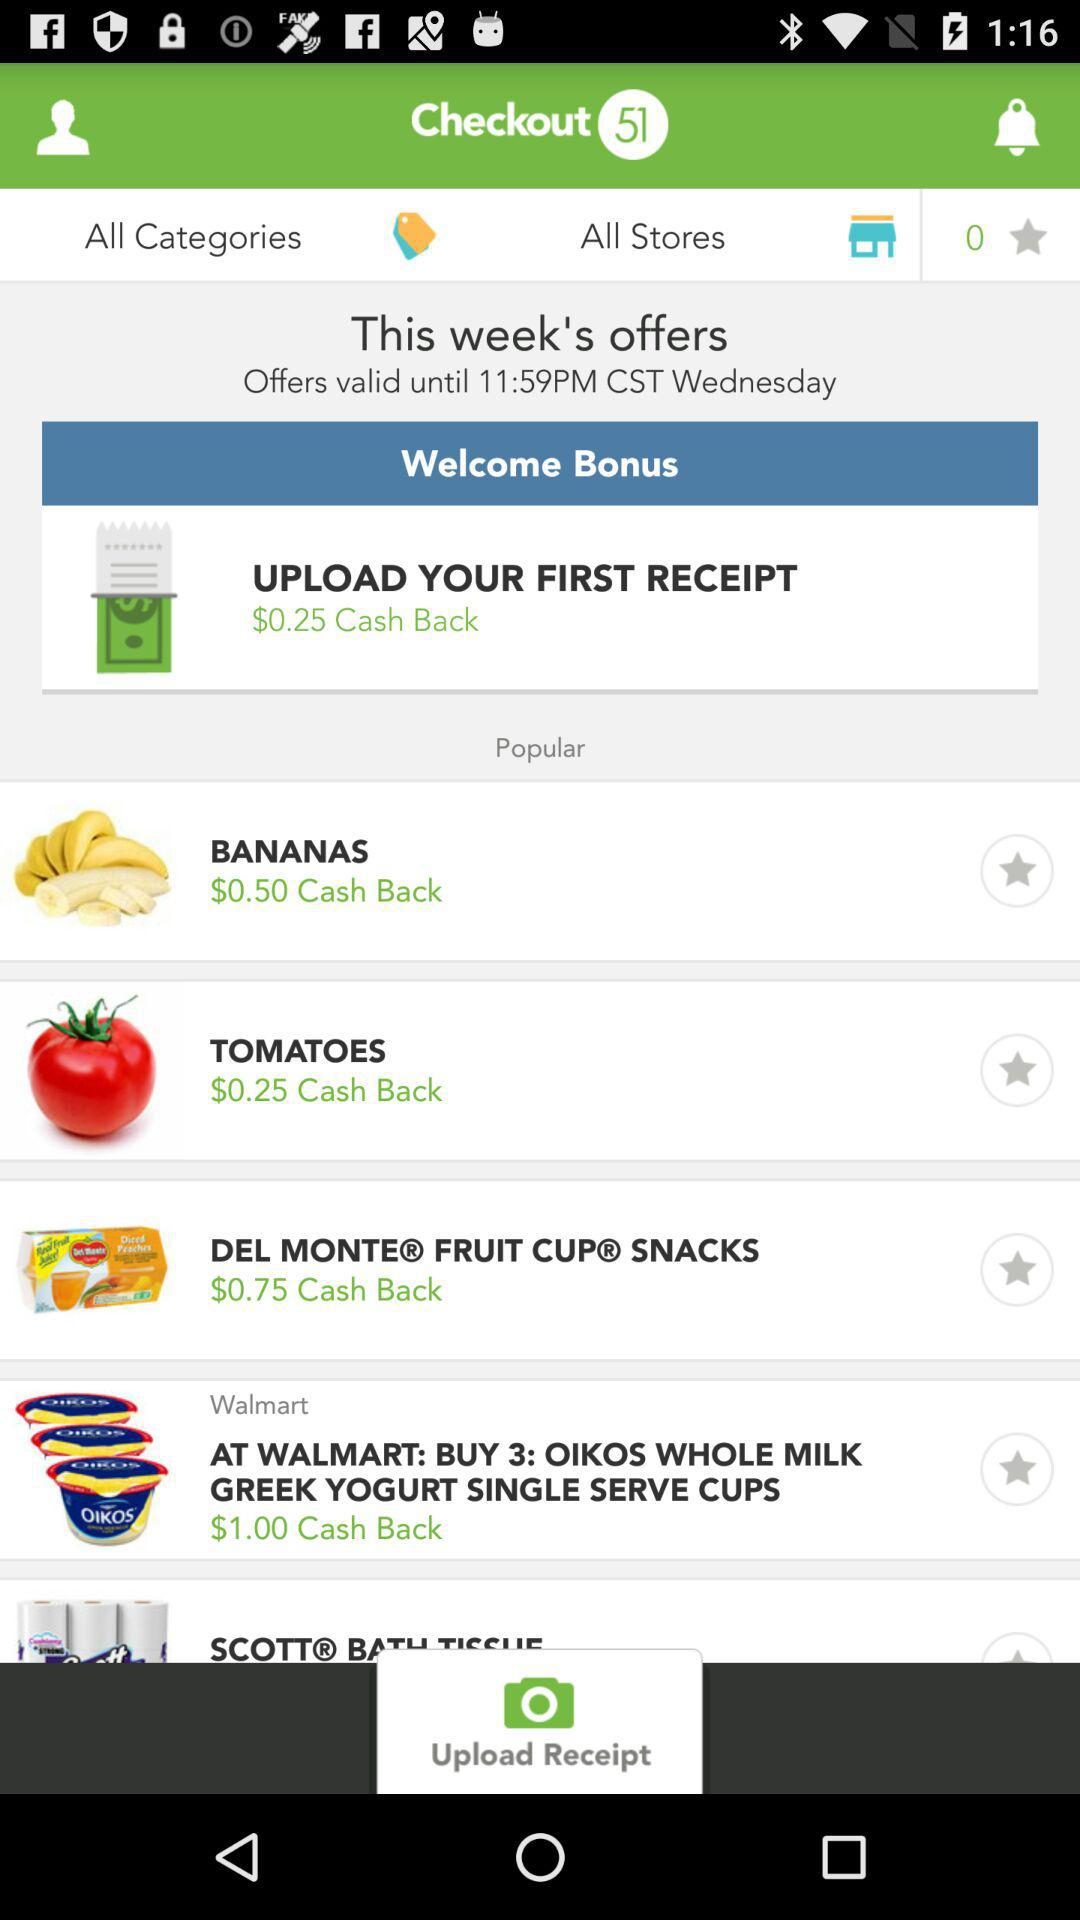How much cashback can be received as a welcome bonus? A cashback of $0.25 can be received as a welcome bonus. 